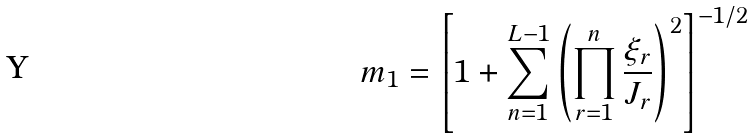Convert formula to latex. <formula><loc_0><loc_0><loc_500><loc_500>m _ { 1 } = \left [ 1 + \sum _ { n = 1 } ^ { L - 1 } \left ( \prod _ { r = 1 } ^ { n } \frac { \xi _ { r } } { J _ { r } } \right ) ^ { 2 } \right ] ^ { - 1 / 2 }</formula> 